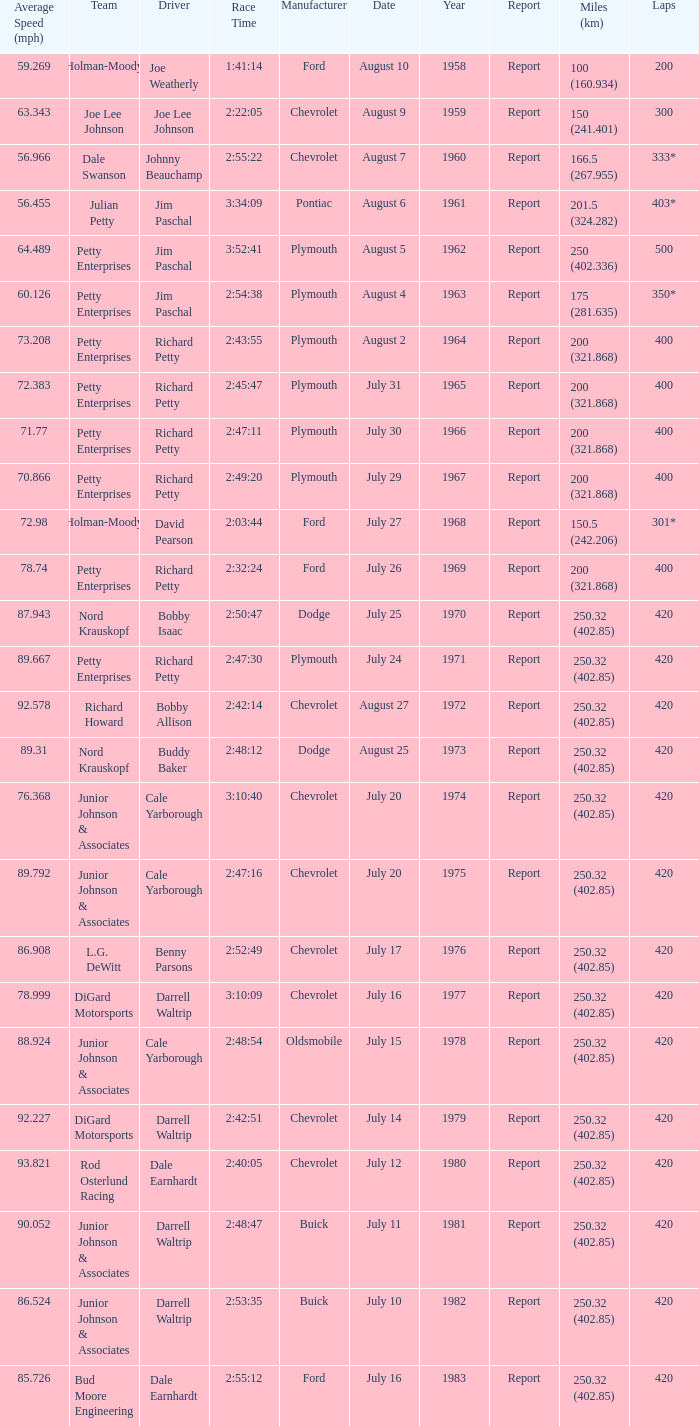How many races did Cale Yarborough win at an average speed of 88.924 mph? 1.0. 